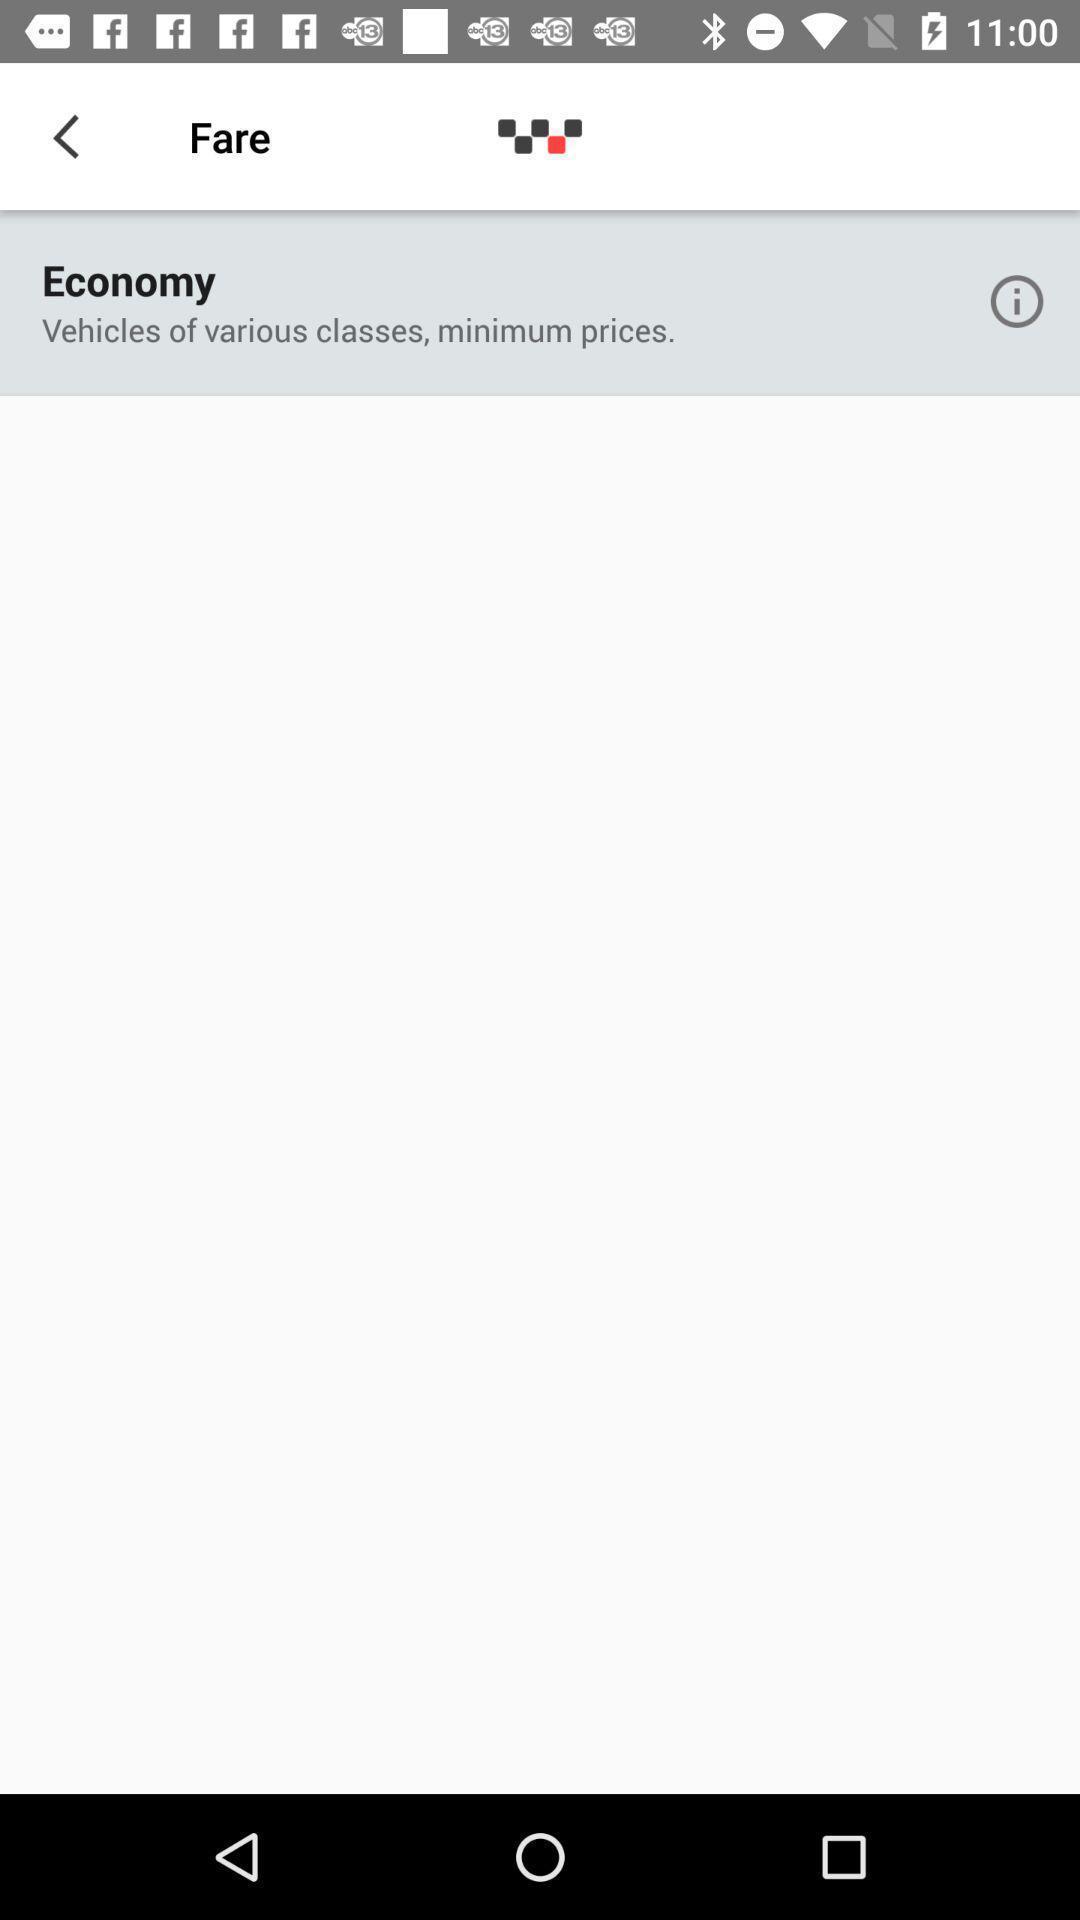Give me a summary of this screen capture. Page showing information of vehicles. 